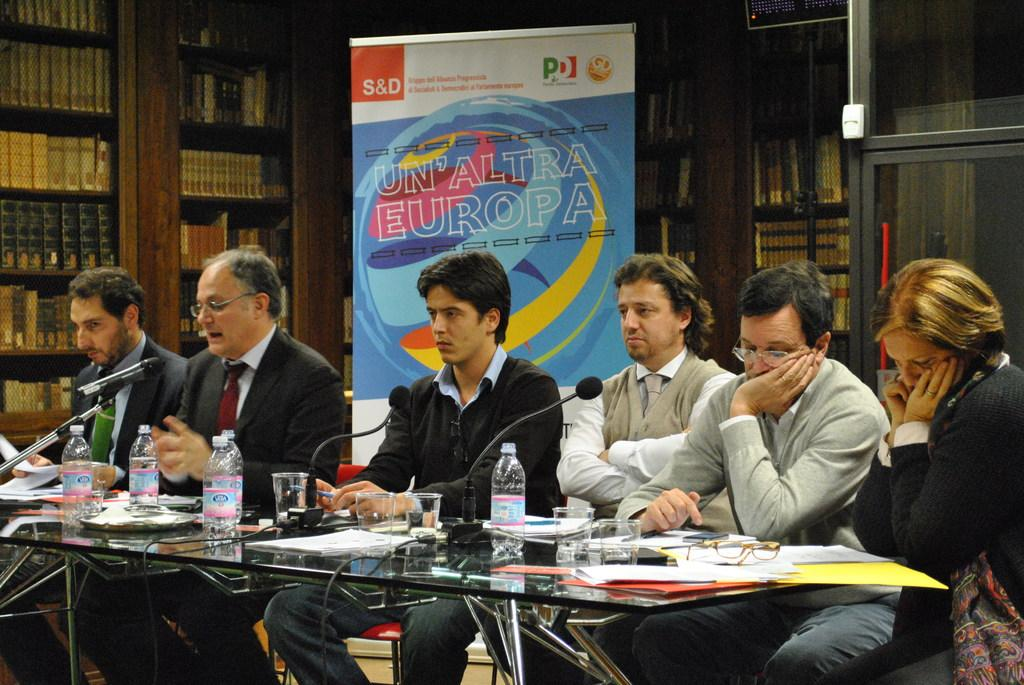<image>
Create a compact narrative representing the image presented. A group of people are sitting at a desk with microphones in it and a sign behind them that says Un Altra Europa. 